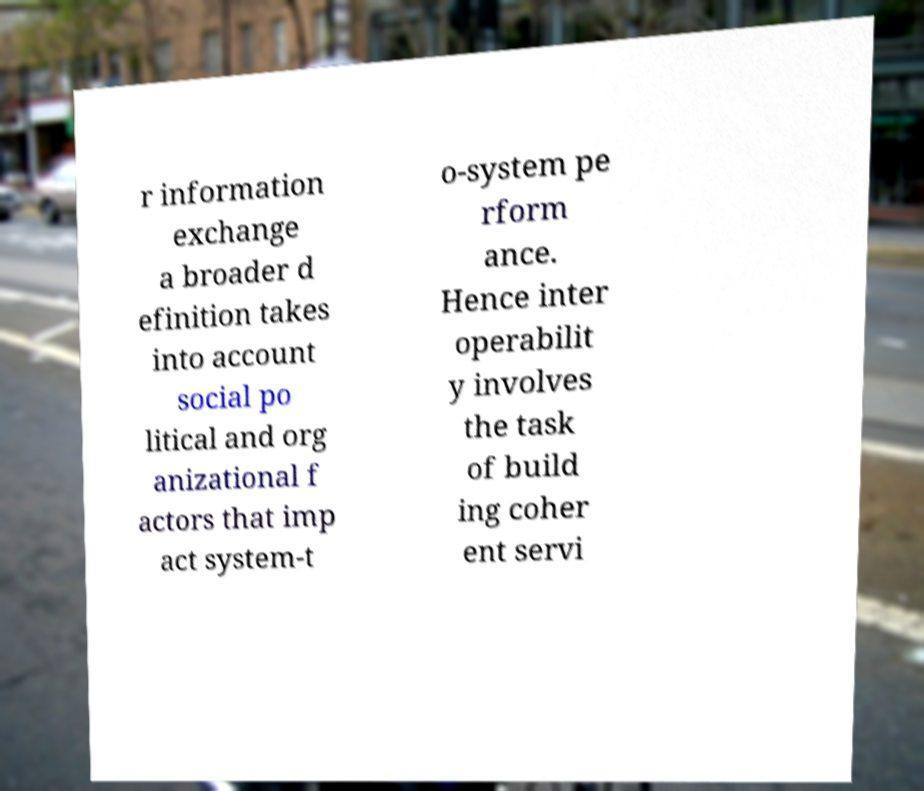Please read and relay the text visible in this image. What does it say? r information exchange a broader d efinition takes into account social po litical and org anizational f actors that imp act system-t o-system pe rform ance. Hence inter operabilit y involves the task of build ing coher ent servi 